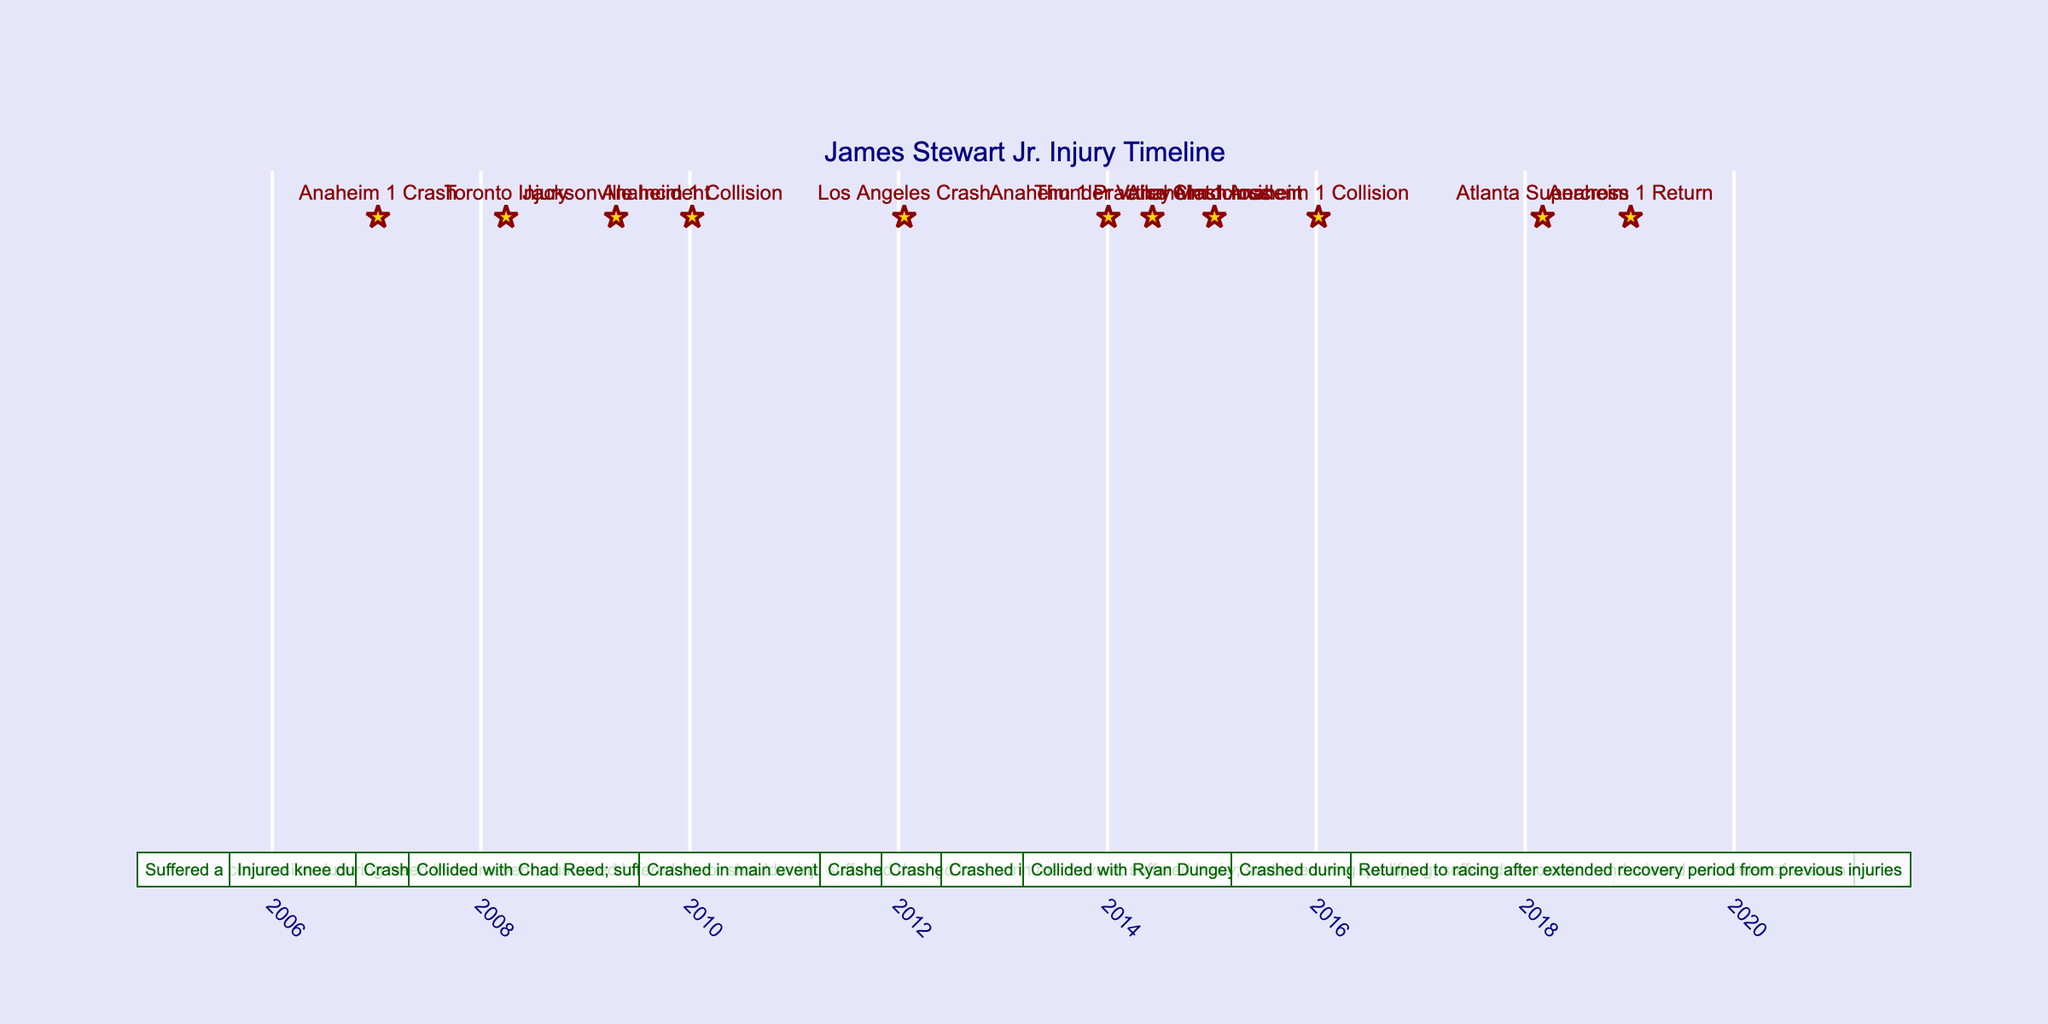What injury did James Stewart sustain on January 6, 2007? On January 6, 2007, during practice at Anaheim, James Stewart suffered a concussion. The description in the timeline specifically states that he missed the main event due to this injury.
Answer: Concussion How many times did James Stewart miss a race due to injury? By reviewing the table entries, James missed races due to injuries on three occasions: Toronto in 2008, Los Angeles in 2012, and Anaheim practice crash in 2014. Each of these events has a corresponding entry indicating he missed the next race or races.
Answer: Three times Was there any instance where he crashed but continued racing? Yes, there are two instances in the table where James Stewart crashed but continued to compete: in Jacksonville in 2009, where he sustained bruised ribs, and in Anaheim in 2015, where he suffered a bruised shoulder. Both events describe him continuing in the series afterward.
Answer: Yes What was the time gap between the first and last entries in the timeline? The first entry is from January 6, 2007, and the last entry is from January 5, 2019. To find the time gap, calculate the difference: From January 6, 2007, to January 5, 2019, is almost 12 years (actually one day short of 12 years).
Answer: Almost 12 years Which two events resulted in a concussion for James Stewart? Two events in the timeline are associated with concussions: the first occurred on January 6, 2007, during practice in Anaheim, and the second on March 3, 2018, during qualifying at Atlanta Supercross. Each entry includes the specific injury and its context.
Answer: Two events How many injuries occurred during practice sessions as opposed to races? From the table, there were three instances of injuries during practice: Anaheim on January 4, 2014, and both occurrences before the various main events. The other entries occurred during actual race events or heat races. Thus, there are two injuries in races.
Answer: Three in practice, two in races Did James Stewart return to racing after missing a significant period due to injuries? Yes, he returned to racing on January 5, 2019, after an extended recovery period from his previous injuries. The timeline indicates he had been absent from competition prior to this entry.
Answer: Yes What was the consequence of James Stewart's crash on June 7, 2014? James Stewart crashed during the Thunder Valley Motocross event on June 7, 2014, resulting in a broken wrist which caused him to end his outdoor season early. The description clearly states the injury and its effect on his racing schedule.
Answer: Broken wrist, ended outdoor season early 